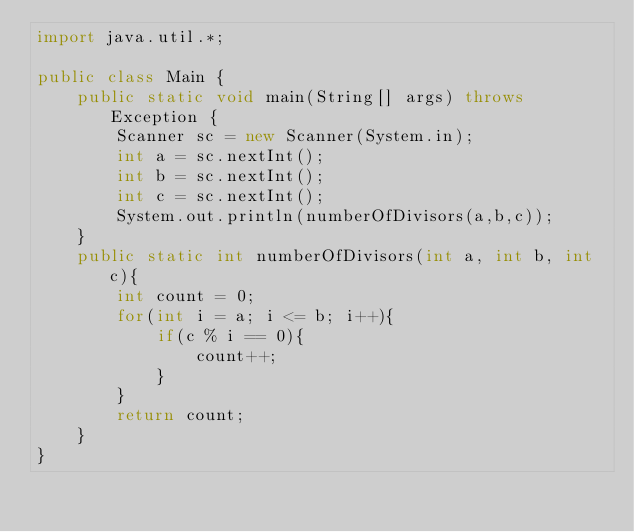<code> <loc_0><loc_0><loc_500><loc_500><_Java_>import java.util.*;

public class Main {
    public static void main(String[] args) throws Exception {
        Scanner sc = new Scanner(System.in);
        int a = sc.nextInt();
        int b = sc.nextInt();
        int c = sc.nextInt();
        System.out.println(numberOfDivisors(a,b,c));
    }
    public static int numberOfDivisors(int a, int b, int c){
        int count = 0;
        for(int i = a; i <= b; i++){
            if(c % i == 0){
                count++;
            }
        }
        return count;
    }
}
</code> 